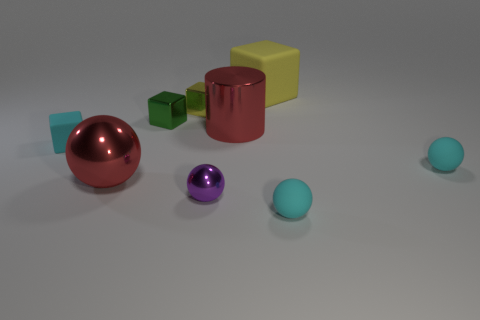Subtract all cyan cubes. How many cubes are left? 3 Subtract all brown blocks. How many cyan spheres are left? 2 Add 1 purple shiny balls. How many objects exist? 10 Subtract 1 cubes. How many cubes are left? 3 Subtract all red balls. How many balls are left? 3 Add 6 rubber things. How many rubber things exist? 10 Subtract 0 gray blocks. How many objects are left? 9 Subtract all blocks. How many objects are left? 5 Subtract all brown spheres. Subtract all red blocks. How many spheres are left? 4 Subtract all green shiny blocks. Subtract all tiny rubber cylinders. How many objects are left? 8 